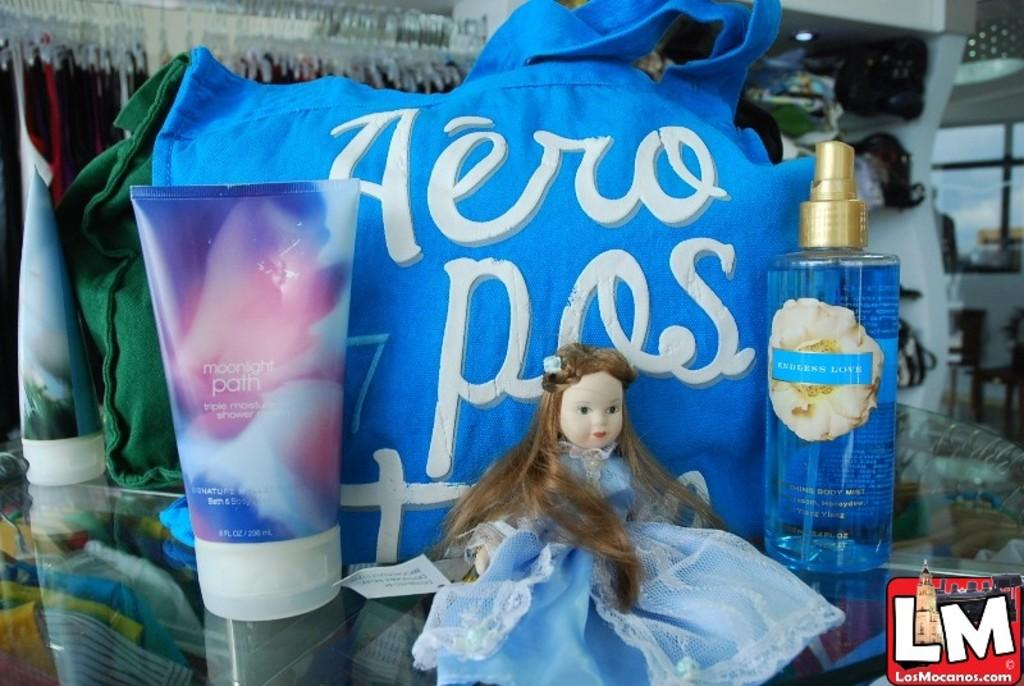How many tubes are visible in the image? There are 2 tubes in the image. What is the main object in the image? There is a perfume in the image. What other object can be seen in the image? There is a doll in the image. What can be seen in the background of the image? There are hangers, a wall, a window, and clothes in the background of the image. Can you see a lake in the background of the image? No, there is no lake visible in the image. What type of action is the doll performing in the image? The doll is not performing any action in the image; it is simply present. 